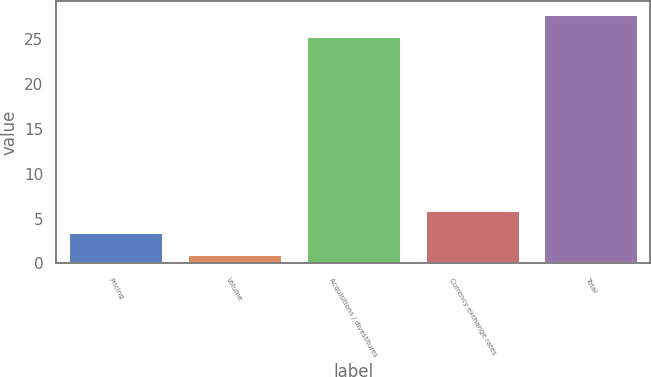Convert chart. <chart><loc_0><loc_0><loc_500><loc_500><bar_chart><fcel>Pricing<fcel>Volume<fcel>Acquisitions / divestitures<fcel>Currency exchange rates<fcel>Total<nl><fcel>3.48<fcel>1<fcel>25.4<fcel>5.96<fcel>27.88<nl></chart> 